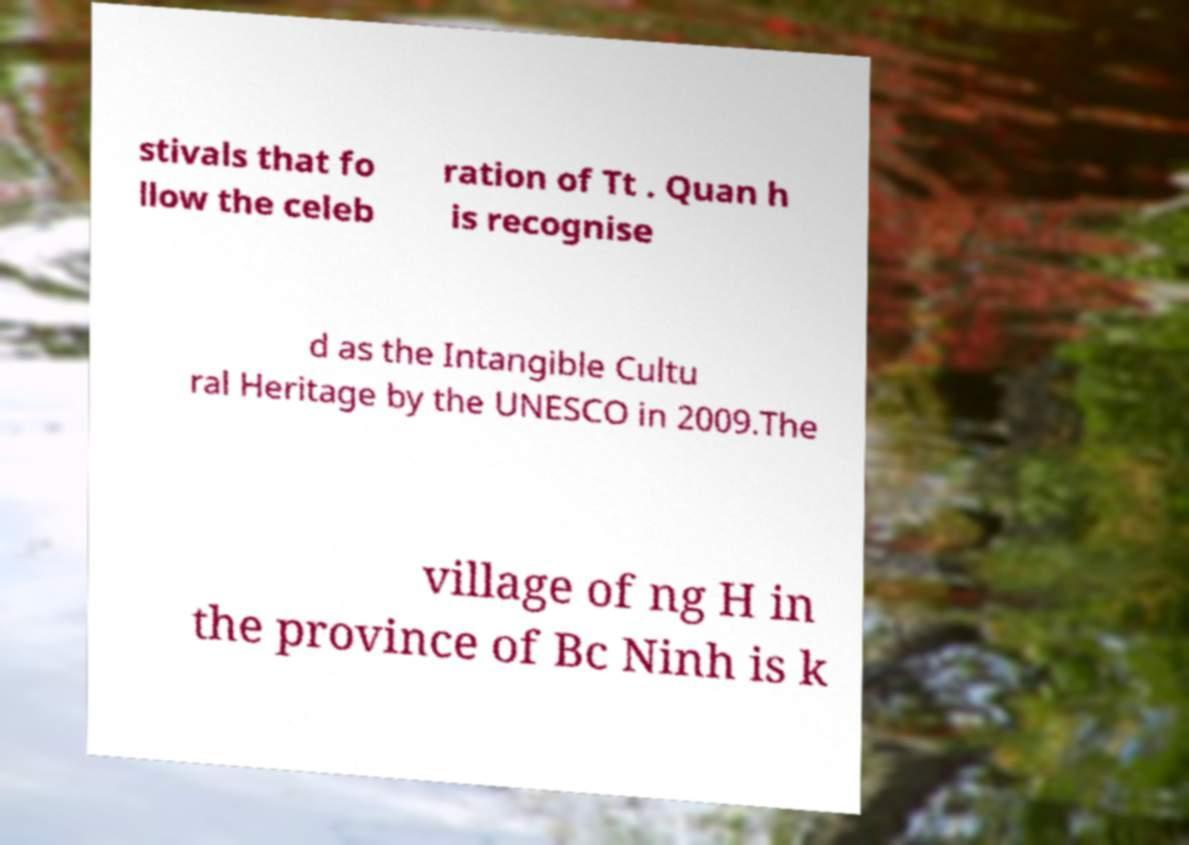Could you extract and type out the text from this image? stivals that fo llow the celeb ration of Tt . Quan h is recognise d as the Intangible Cultu ral Heritage by the UNESCO in 2009.The village of ng H in the province of Bc Ninh is k 